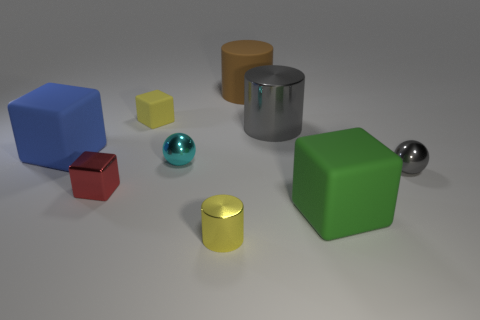What color is the other large metallic thing that is the same shape as the large brown object?
Your answer should be very brief. Gray. What number of small metal cubes have the same color as the large shiny thing?
Your answer should be very brief. 0. Is the color of the small metallic cylinder the same as the tiny rubber object?
Provide a short and direct response. Yes. How many objects are either matte objects to the right of the matte cylinder or green shiny objects?
Make the answer very short. 1. There is a large matte block that is right of the large rubber cylinder that is behind the large rubber block on the right side of the red block; what color is it?
Give a very brief answer. Green. What color is the large object that is made of the same material as the small cylinder?
Make the answer very short. Gray. What number of large brown cylinders have the same material as the large gray object?
Give a very brief answer. 0. There is a matte cube to the left of the yellow matte object; does it have the same size as the large gray metallic object?
Provide a short and direct response. Yes. There is a cylinder that is the same size as the cyan metal thing; what color is it?
Offer a very short reply. Yellow. What number of big rubber things are left of the red object?
Your answer should be compact. 1. 